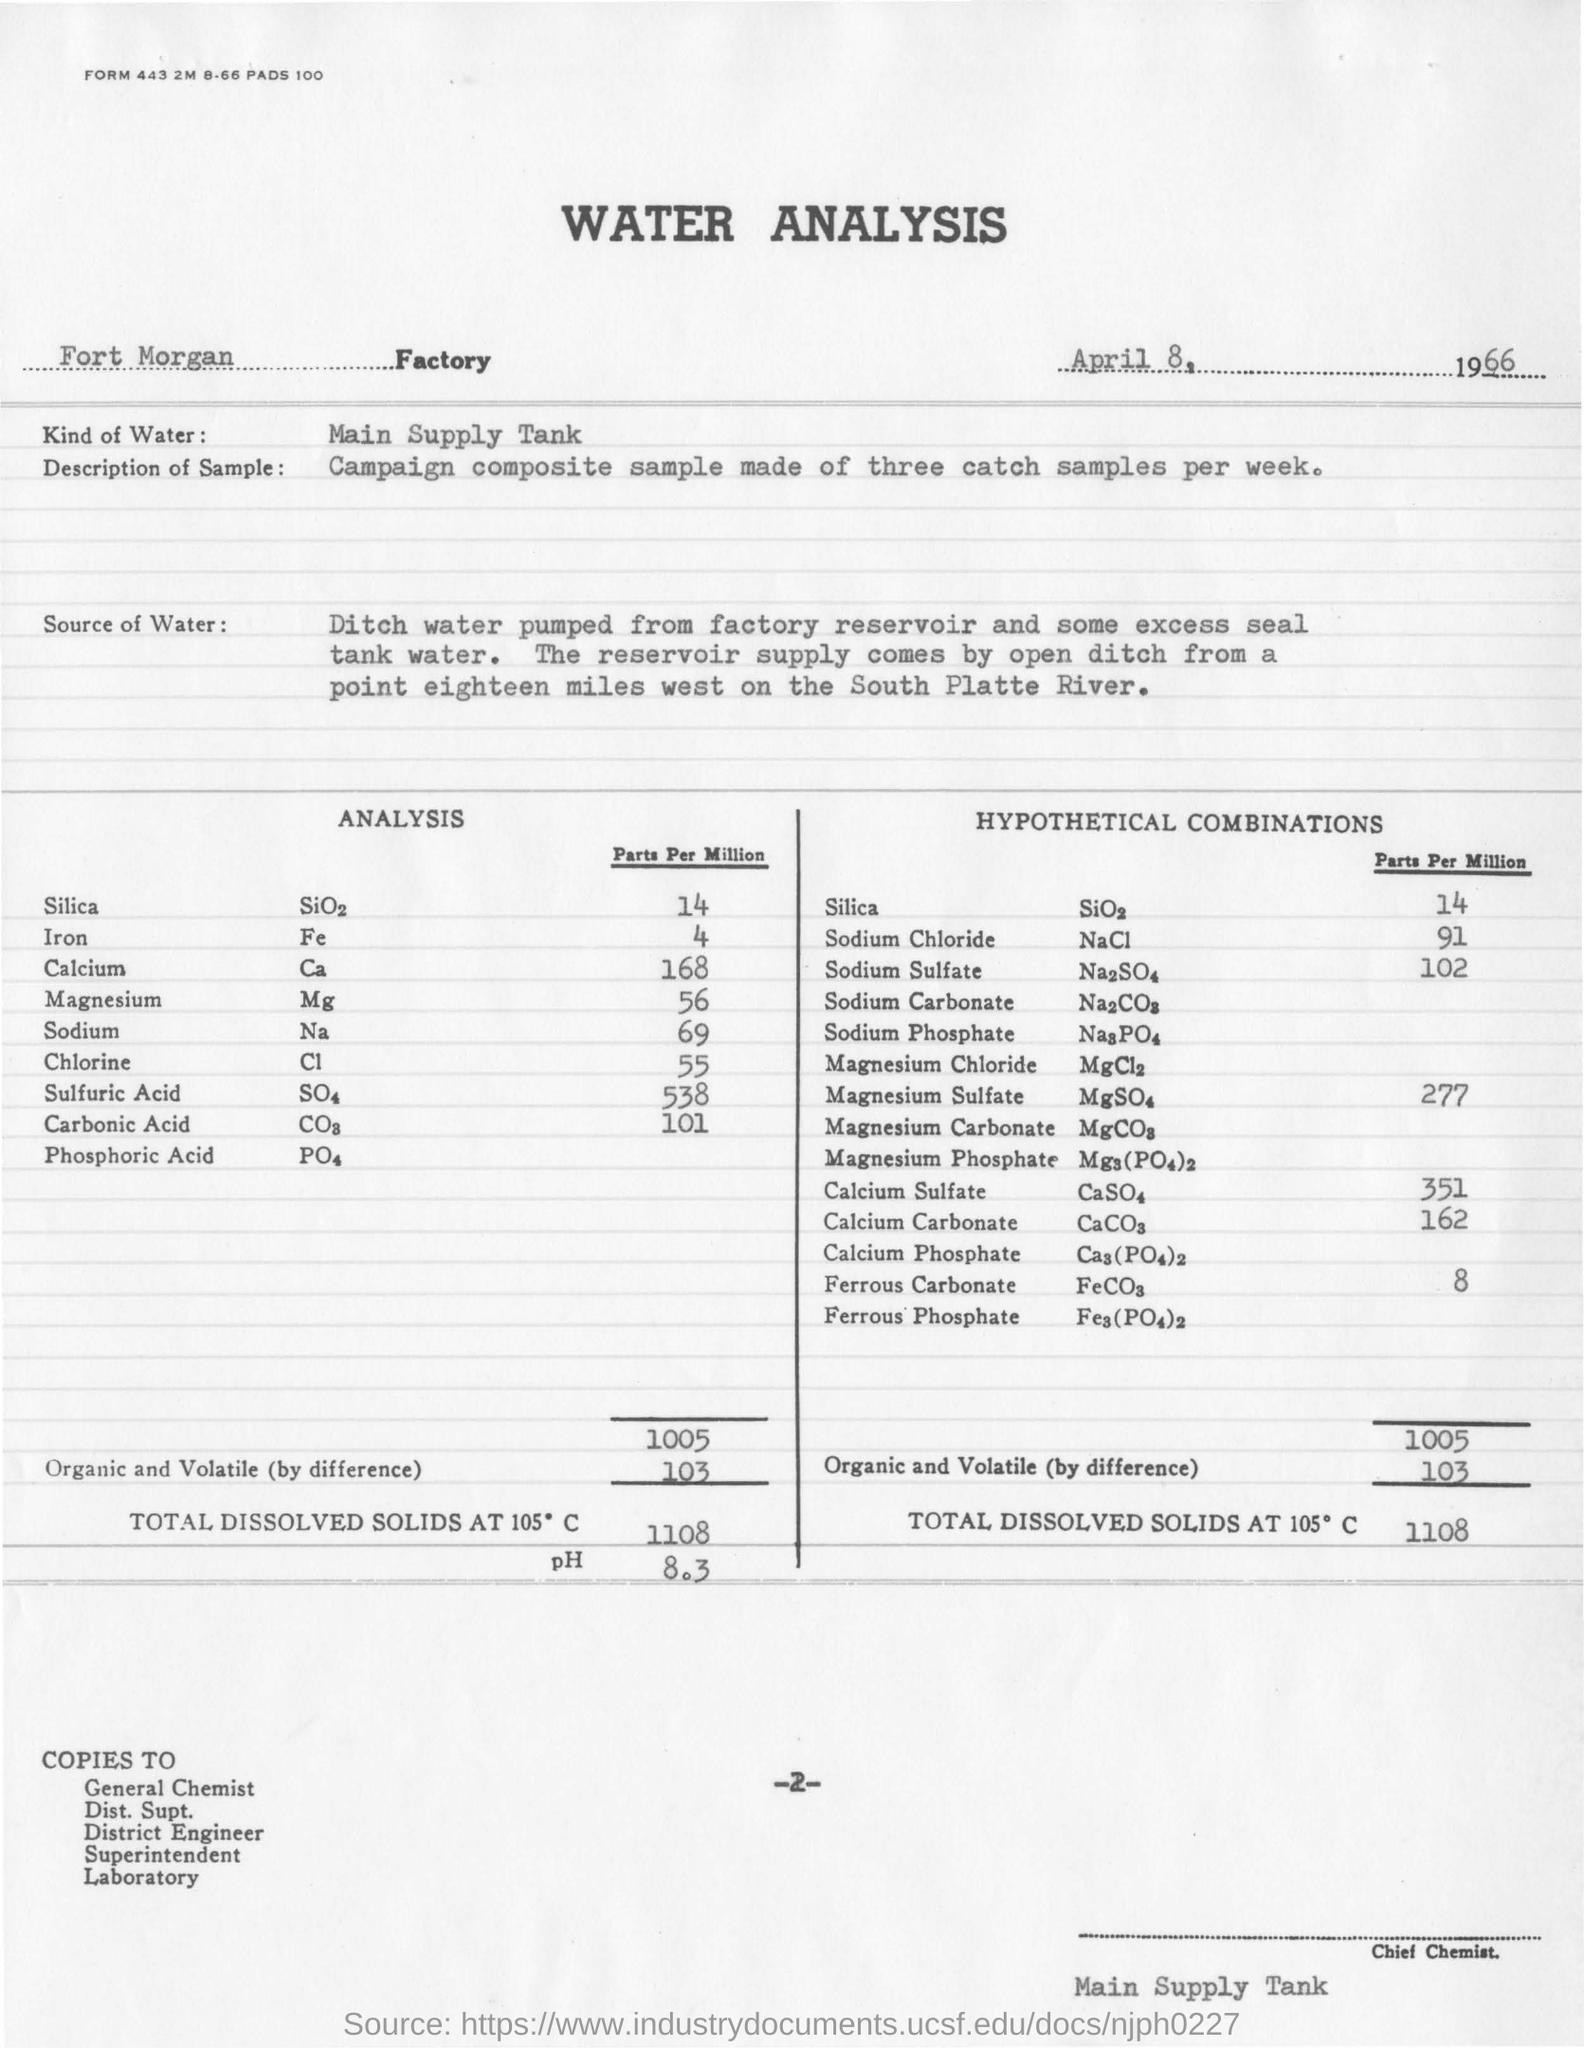What is the date given in the document?
Keep it short and to the point. April 8, 1966. What  kind of water is used in the analysis?
Make the answer very short. Main supply tank. As per the form what is "Kind of water"?
Ensure brevity in your answer.  Main Supply Tank. 